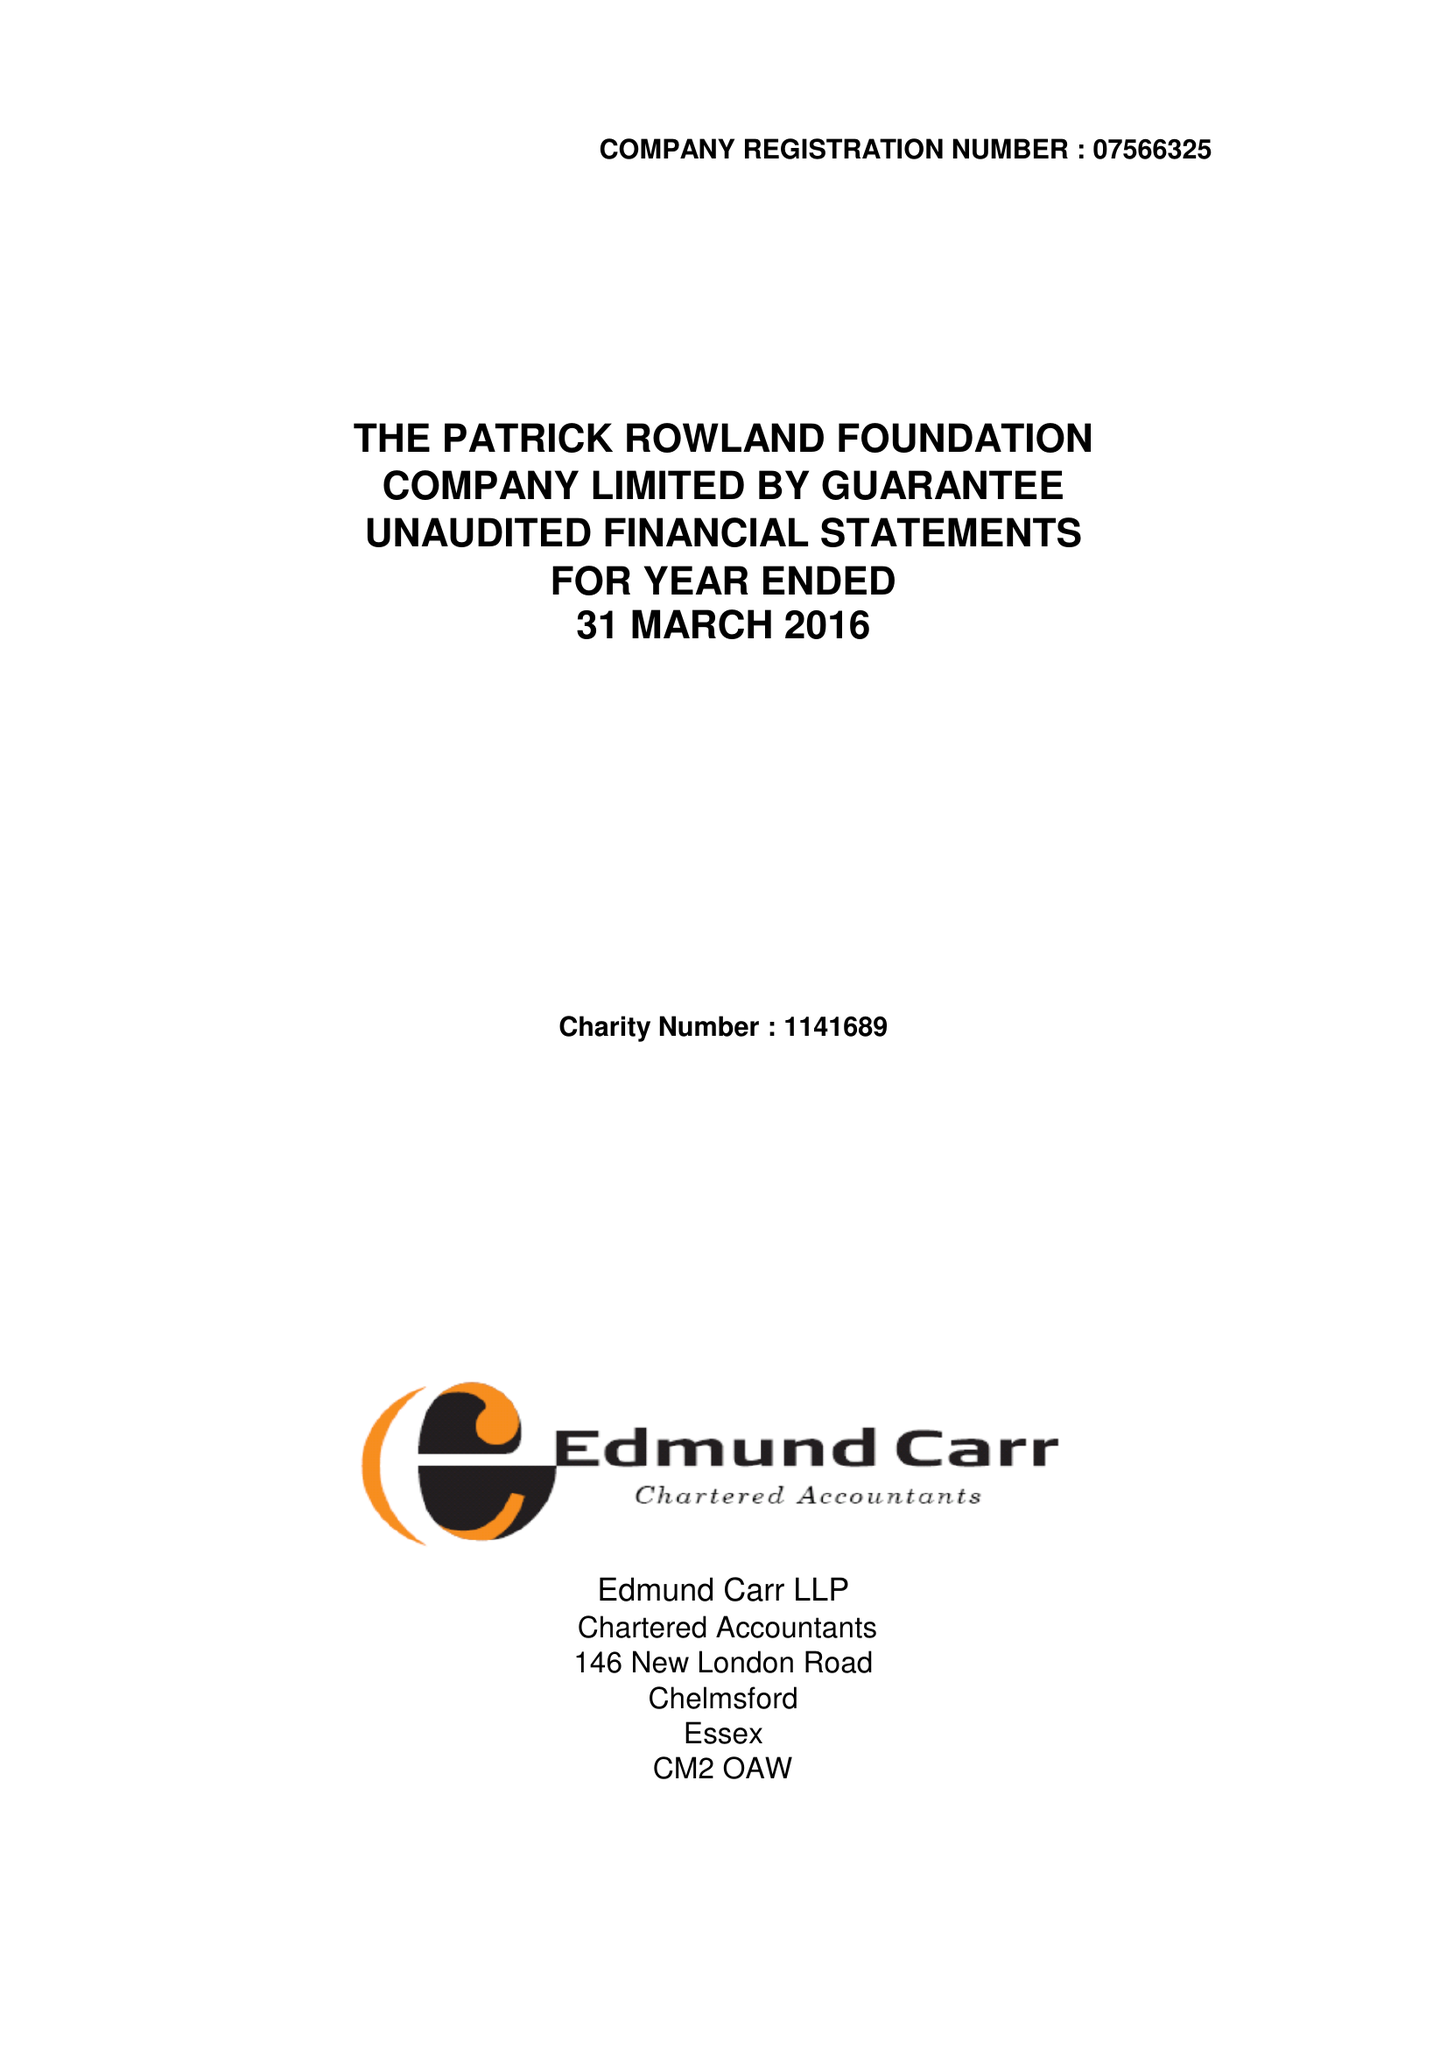What is the value for the spending_annually_in_british_pounds?
Answer the question using a single word or phrase. 35837.00 